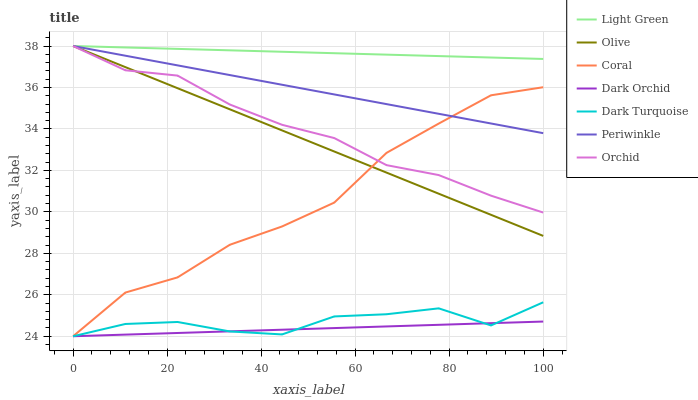Does Dark Orchid have the minimum area under the curve?
Answer yes or no. Yes. Does Light Green have the maximum area under the curve?
Answer yes or no. Yes. Does Coral have the minimum area under the curve?
Answer yes or no. No. Does Coral have the maximum area under the curve?
Answer yes or no. No. Is Dark Orchid the smoothest?
Answer yes or no. Yes. Is Coral the roughest?
Answer yes or no. Yes. Is Coral the smoothest?
Answer yes or no. No. Is Dark Orchid the roughest?
Answer yes or no. No. Does Dark Turquoise have the lowest value?
Answer yes or no. Yes. Does Periwinkle have the lowest value?
Answer yes or no. No. Does Orchid have the highest value?
Answer yes or no. Yes. Does Coral have the highest value?
Answer yes or no. No. Is Dark Turquoise less than Orchid?
Answer yes or no. Yes. Is Olive greater than Dark Turquoise?
Answer yes or no. Yes. Does Orchid intersect Olive?
Answer yes or no. Yes. Is Orchid less than Olive?
Answer yes or no. No. Is Orchid greater than Olive?
Answer yes or no. No. Does Dark Turquoise intersect Orchid?
Answer yes or no. No. 